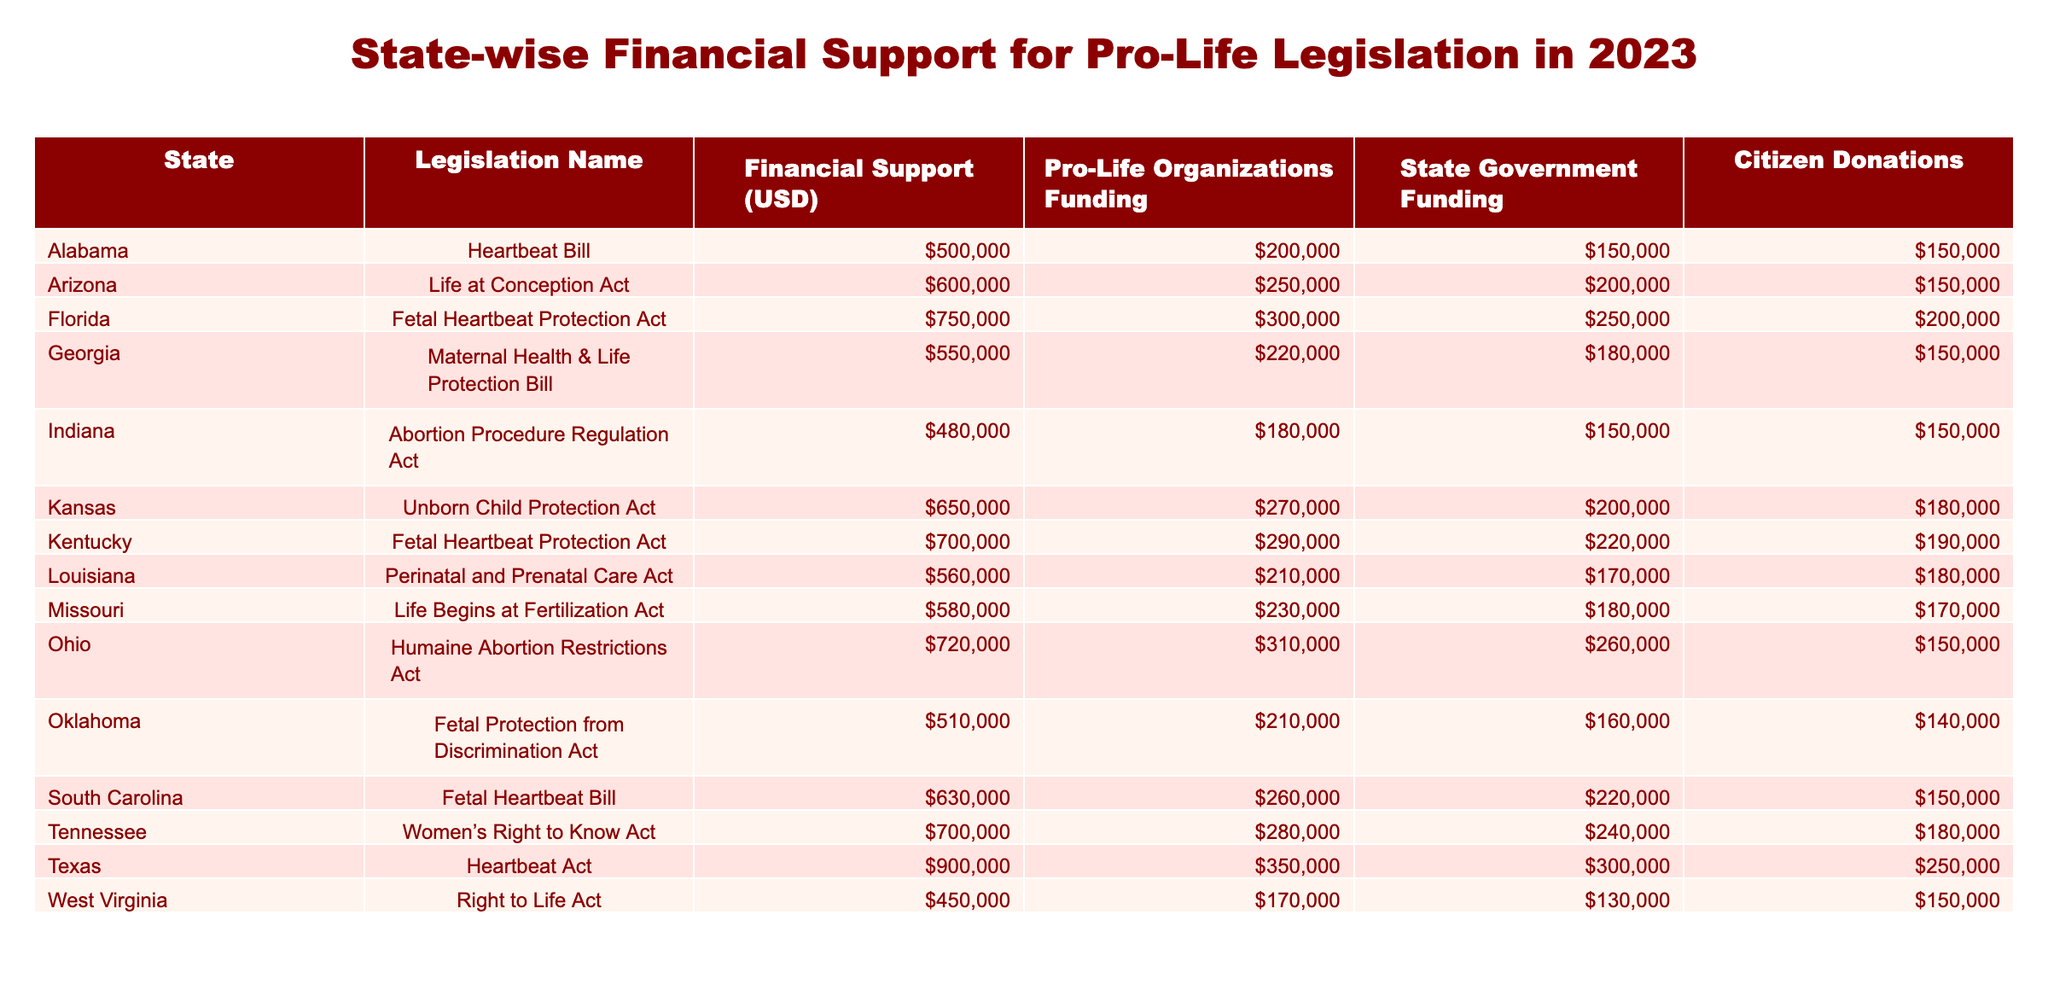What is the total financial support for pro-life legislation in Texas? In the table, Texas has a financial support amount of 900,000 USD listed under "Financial Support (USD)." Therefore, the total financial support for pro-life legislation in Texas is simply that amount.
Answer: 900,000 USD Which state has the highest funding from citizen donations? By looking at the "Citizen Donations" column, I can see that Texas has the highest amount, which is 250,000 USD. It is important to check each state’s citizen donations systematically to confirm Texas is indeed the highest.
Answer: 250,000 USD How much more financial support does Florida receive compared to West Virginia? Florida's financial support is 750,000 USD, and West Virginia's is 450,000 USD. To find the difference, subtract West Virginia's amount from Florida's: 750,000 - 450,000 = 300,000.
Answer: 300,000 USD Is the combined funding from state governments and citizen donations for Kansas greater than the funding from pro-life organizations? Kansas has state government funding of 200,000 USD and citizen donations of 180,000 USD, which when added gives a total of 200,000 + 180,000 = 380,000 USD. Pro-life organizations' funding is 270,000 USD. Since 380,000 is greater than 270,000, the answer is yes.
Answer: Yes What is the average amount of financial support across all states listed in the table? To find the average amount of financial support, sum all the values in the "Financial Support (USD)" column: 500,000 + 600,000 + 750,000 + 550,000 + 480,000 + 650,000 + 700,000 + 560,000 + 580,000 + 720,000 + 510,000 + 630,000 + 700,000 + 900,000 + 450,000 = 8,800,000 USD. There are 15 states, so divide the total by 15: 8,800,000 / 15 = 586,667 USD.
Answer: 586,667 USD Which state has the least funding from pro-life organizations? By reviewing the "Pro-Life Organizations Funding" column, I notice that West Virginia has the lowest amount, which is 170,000 USD. It is essential to compare each state’s funding to ensure West Virginia has the least.
Answer: 170,000 USD 